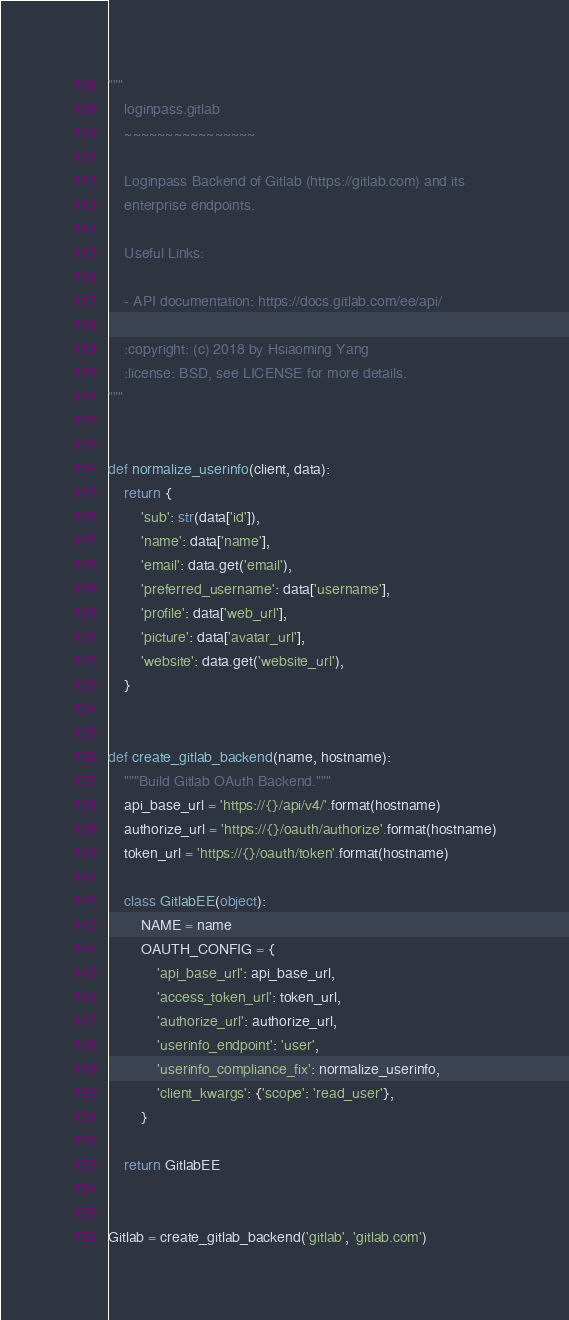<code> <loc_0><loc_0><loc_500><loc_500><_Python_>"""
    loginpass.gitlab
    ~~~~~~~~~~~~~~~~

    Loginpass Backend of Gitlab (https://gitlab.com) and its
    enterprise endpoints.

    Useful Links:

    - API documentation: https://docs.gitlab.com/ee/api/

    :copyright: (c) 2018 by Hsiaoming Yang
    :license: BSD, see LICENSE for more details.
"""


def normalize_userinfo(client, data):
    return {
        'sub': str(data['id']),
        'name': data['name'],
        'email': data.get('email'),
        'preferred_username': data['username'],
        'profile': data['web_url'],
        'picture': data['avatar_url'],
        'website': data.get('website_url'),
    }


def create_gitlab_backend(name, hostname):
    """Build Gitlab OAuth Backend."""
    api_base_url = 'https://{}/api/v4/'.format(hostname)
    authorize_url = 'https://{}/oauth/authorize'.format(hostname)
    token_url = 'https://{}/oauth/token'.format(hostname)

    class GitlabEE(object):
        NAME = name
        OAUTH_CONFIG = {
            'api_base_url': api_base_url,
            'access_token_url': token_url,
            'authorize_url': authorize_url,
            'userinfo_endpoint': 'user',
            'userinfo_compliance_fix': normalize_userinfo,
            'client_kwargs': {'scope': 'read_user'},
        }

    return GitlabEE


Gitlab = create_gitlab_backend('gitlab', 'gitlab.com')
</code> 